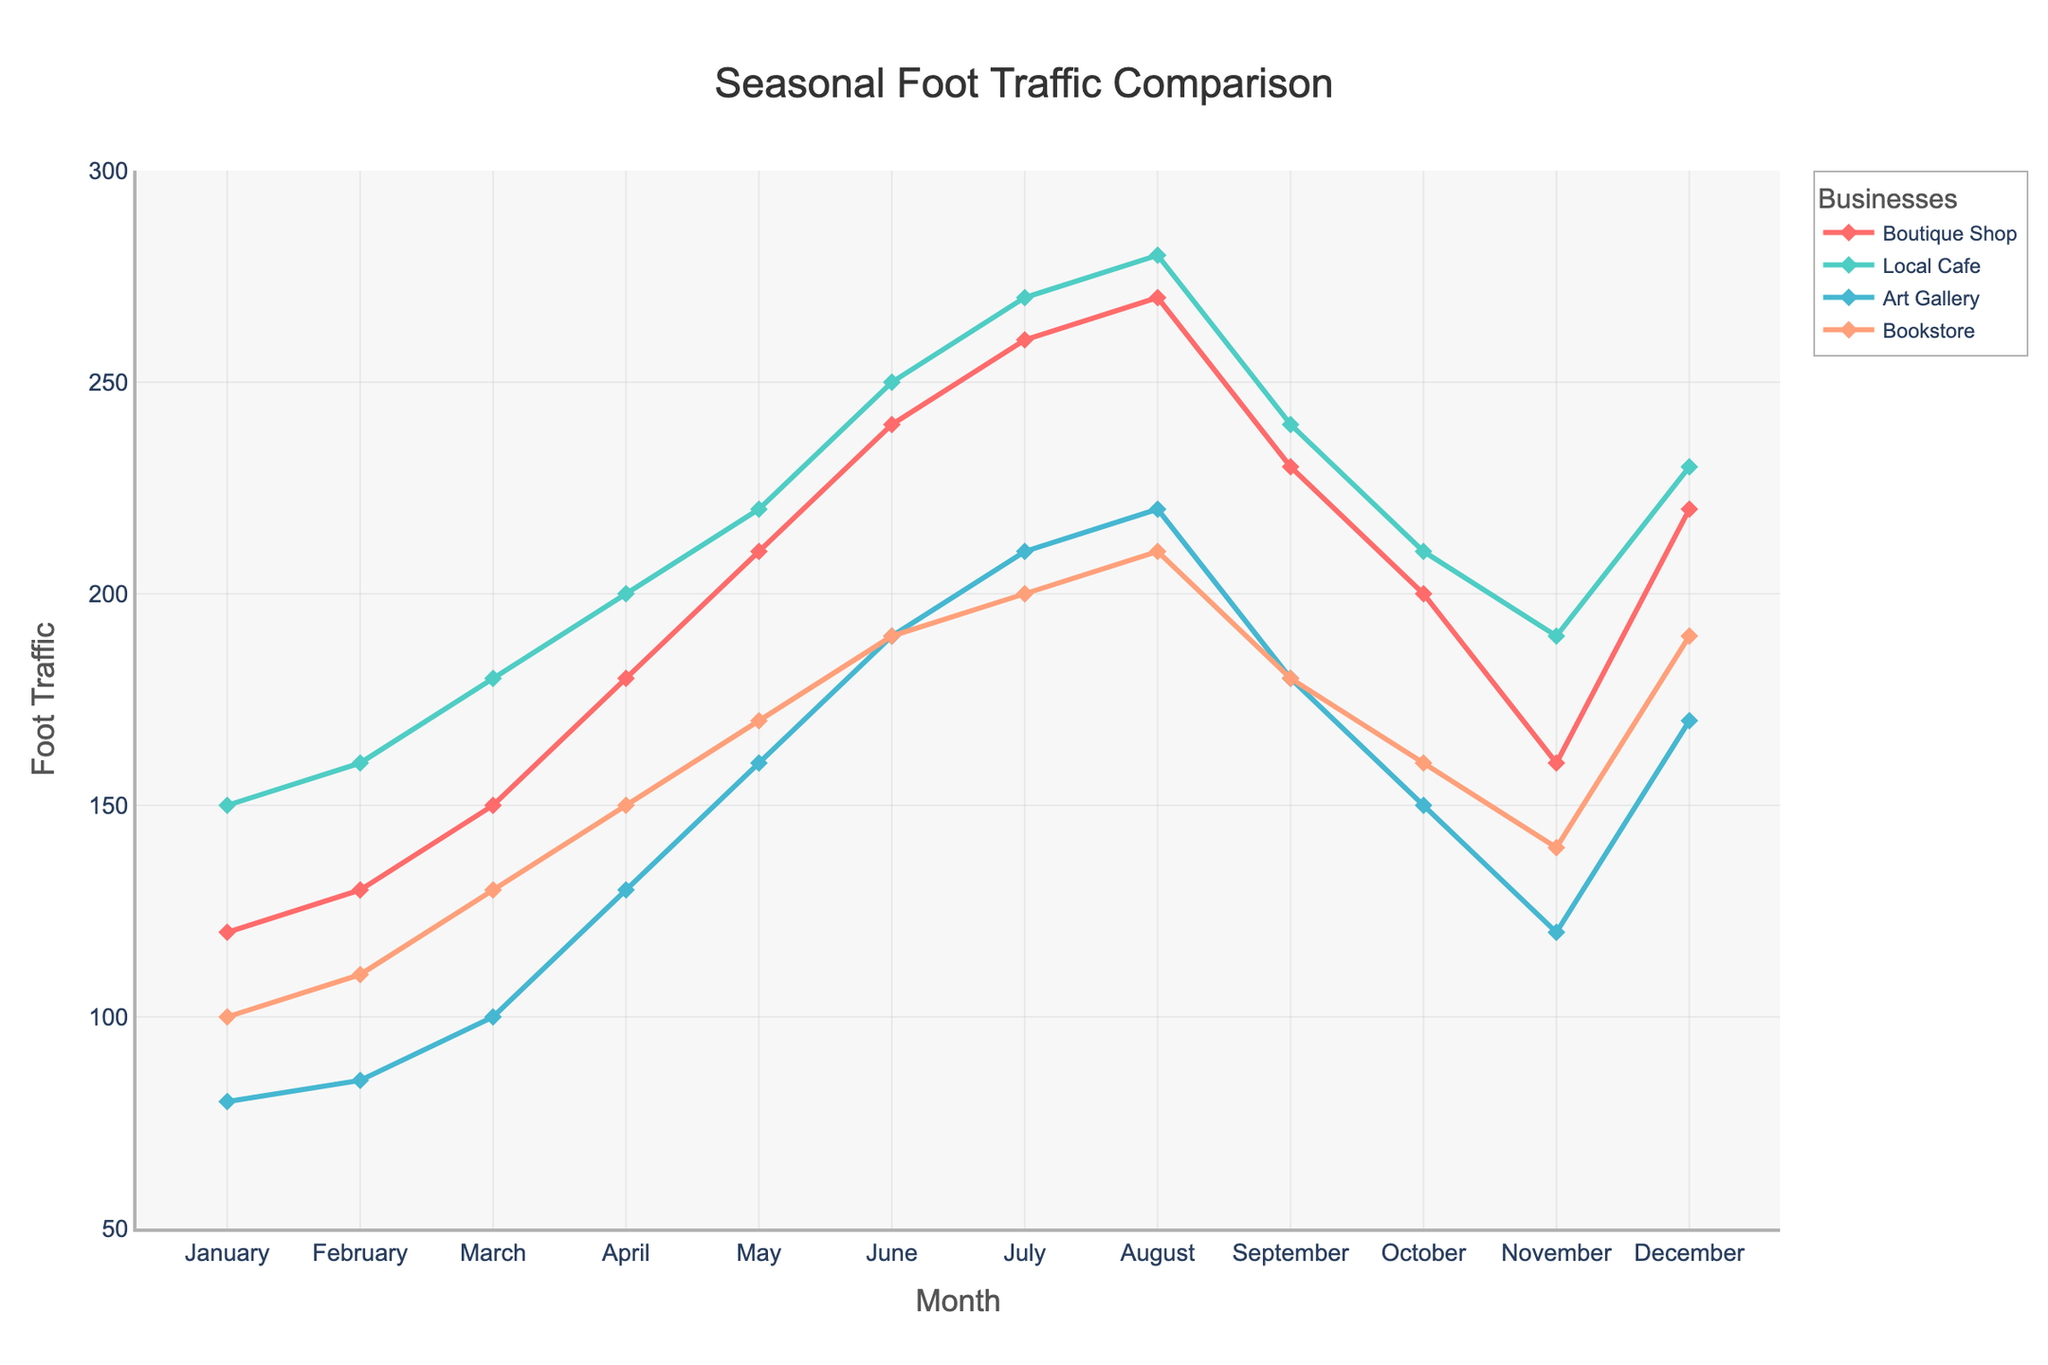Which month has the highest foot traffic for the boutique shop? The highest point on the line representing the boutique shop indicates the maximum foot traffic. The peak for the boutique shop occurs in August.
Answer: August How does the foot traffic in December compare across all four businesses? Inspect the values in December across all four lines. The boutique shop has 220, the local cafe has 230, the art gallery has 170, and the bookstore has 190. The local cafe has the highest foot traffic, followed by the boutique shop, the bookstore, and the art gallery.
Answer: Local Cafe > Boutique Shop > Bookstore > Art Gallery What is the difference in foot traffic between July and November for the boutique shop? Look at the values for the boutique shop in July and November. July has 260 and November has 160. The difference is 260 - 160 = 100.
Answer: 100 In which months does the art gallery have the lowest foot traffic? The lowest points on the line representing the art gallery indicate the minimum foot traffic. January and February both show the lowest value of 80 and 85 respectively.
Answer: January, February What is the average foot traffic for the bookstore from June to August? Sum the values for the bookstore from June to August and then divide by the number of months. (190 + 200 + 210) / 3 = 600 / 3 = 200.
Answer: 200 Compare the overall trend of foot traffic for the boutique shop and the local cafe. Which one shows a more consistent increase? Observe the slopes of the lines representing the boutique shop and the local cafe. The boutique shop shows more consistent increases each month compared to the more variable increases of the local cafe.
Answer: Boutique Shop During which month does the local cafe have its sharpest increase in foot traffic? Compare the month-to-month increases for the local cafe. The sharpest increase is from March (180) to April (200), a difference of 20.
Answer: April How does the foot traffic for the boutique shop in March compare to the art gallery in the same month? Look at the values for March for both the boutique shop and the art gallery. The boutique shop has 150 and the art gallery has 100.
Answer: Boutique Shop > Art Gallery What is the sum of foot traffic for all businesses in May? Add the values for all businesses in May. Boutique Shop (210) + Local Cafe (220) + Art Gallery (160) + Bookstore (170) = 760.
Answer: 760 